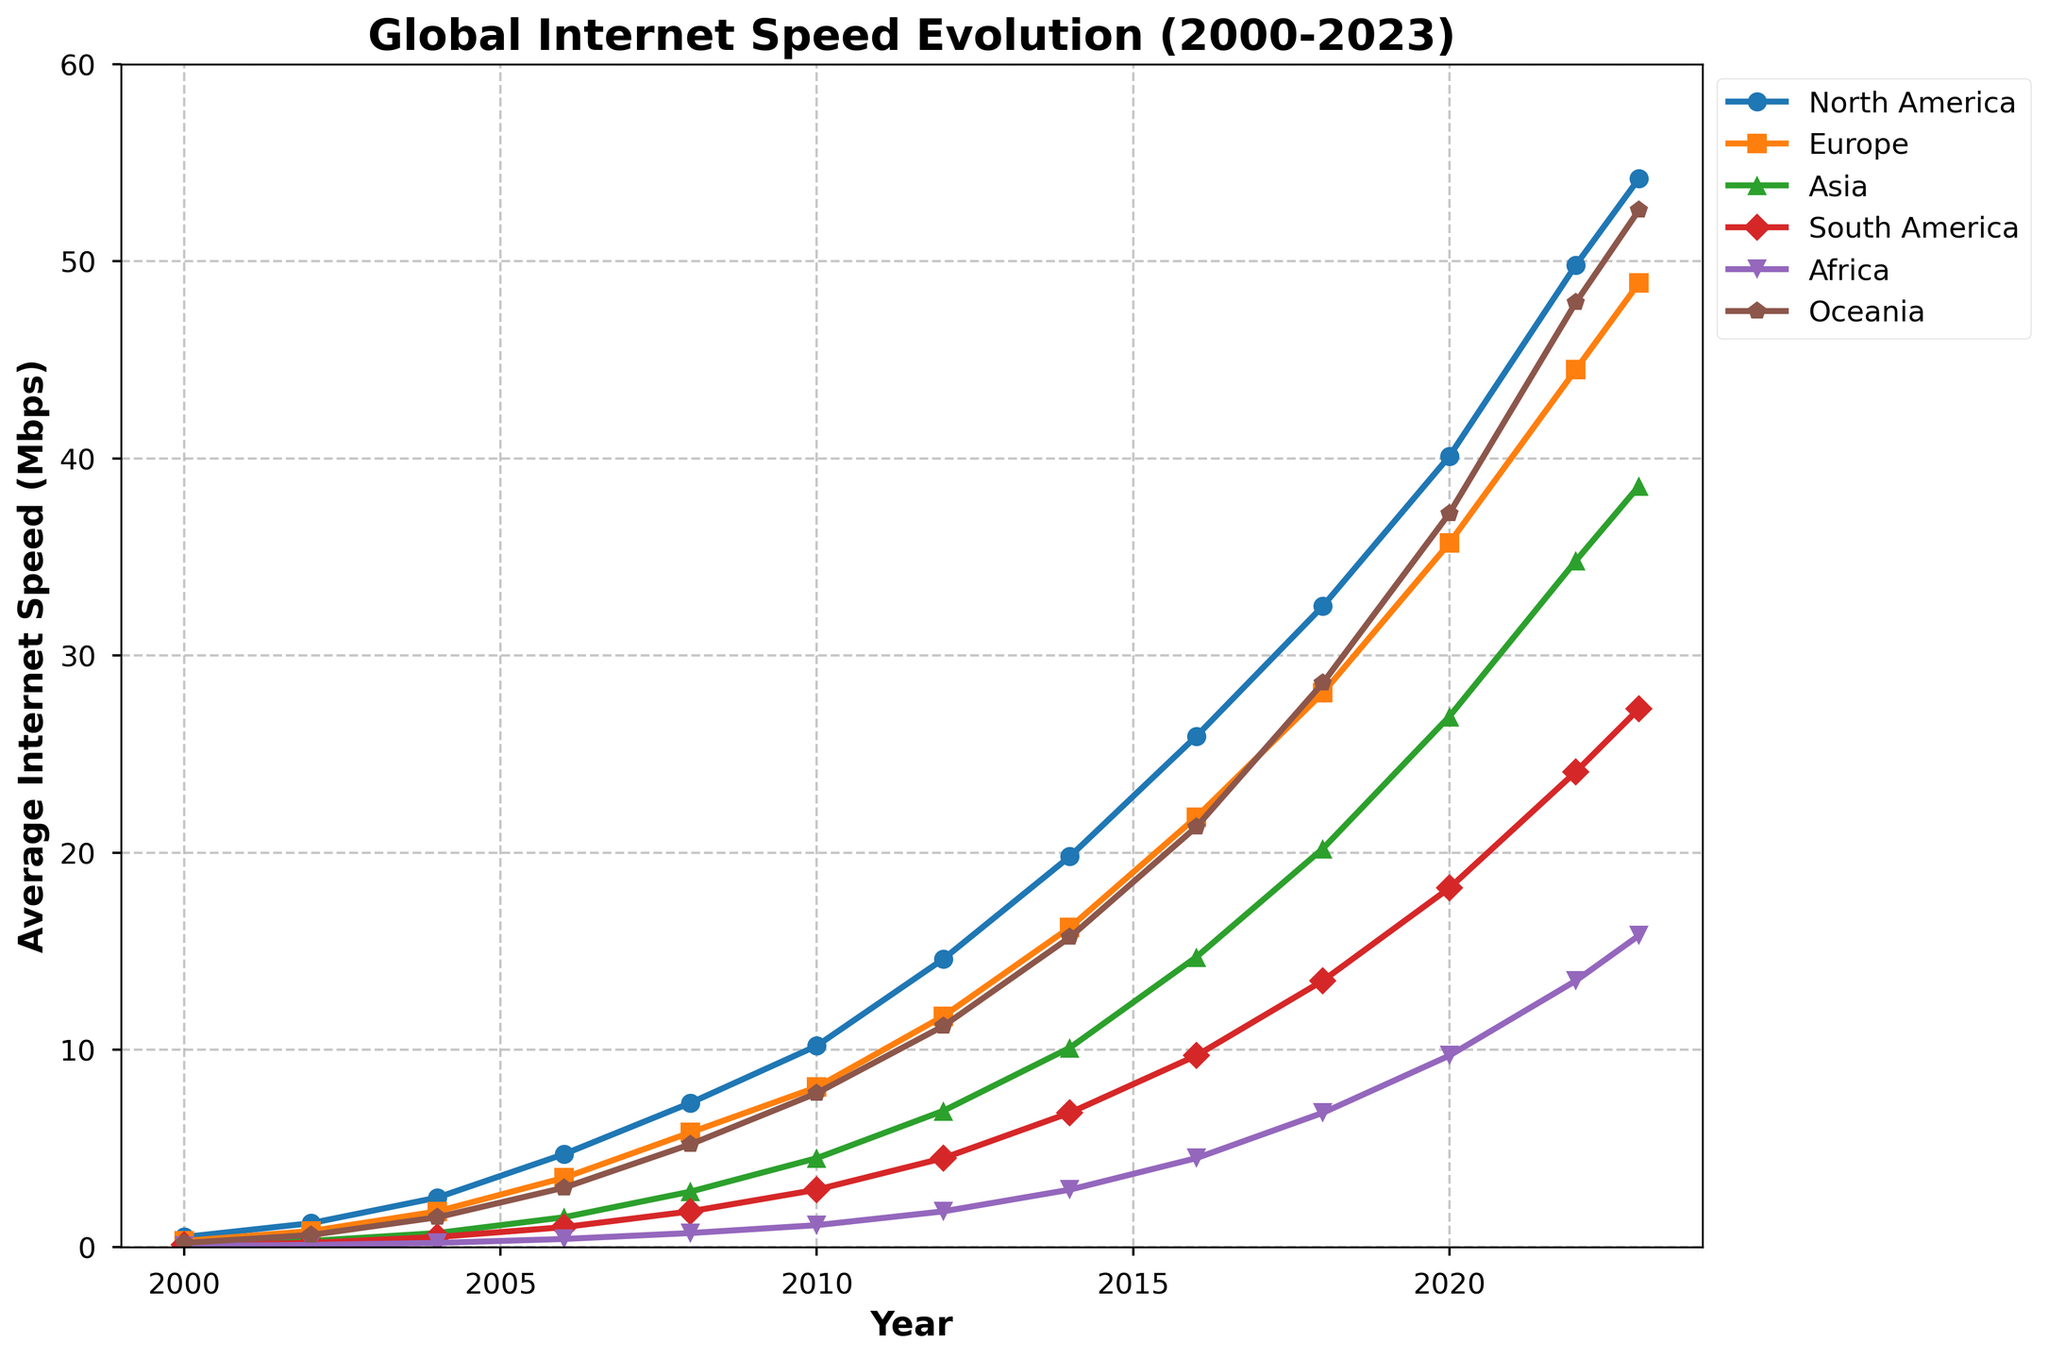Which continent had the highest average internet speed in 2023? By looking at the plot, the curve for Oceania in 2023 is the highest among the continents.
Answer: Oceania What was the average internet speed in Africa in 2010 compared to 2020? In 2010, Africa had an average speed of 1.1 Mbps. By 2020, it had increased to 9.7 Mbps. The increase is calculated as 9.7 - 1.1 = 8.6 Mbps.
Answer: 8.6 Mbps Which two continents had the closest average internet speeds in 2018, and what were those speeds? Observing the 2018 data points, Asia and North America had close values with Asia at 20.2 Mbps and North America at 32.5 Mbps. Among all, the closest speeds are Europe at 28.1 Mbps and Oceania at 28.6 Mbps, with a difference of just 0.5 Mbps.
Answer: Europe and Oceania, 28.1 Mbps and 28.6 Mbps How did the average internet speed in South America change between 2006 and 2018? In 2006, South America's average was 1.0 Mbps, and in 2018, it was 13.5 Mbps. The change is 13.5 - 1.0 = 12.5 Mbps.
Answer: 12.5 Mbps Compare the growth in average internet speed of North America and Asia from 2004 to 2022. Which one grew more, and by how much? In 2004, North America was at 2.5 Mbps and in 2022 at 49.8 Mbps. The increase for North America is 49.8 - 2.5 = 47.3 Mbps. Asia was at 0.7 Mbps in 2004 and 34.8 Mbps in 2022, so its increase is 34.8 - 0.7 = 34.1 Mbps. North America grew more by 47.3 - 34.1 = 13.2 Mbps.
Answer: North America, by 13.2 Mbps What is the approximate difference in average internet speeds between 2000 and 2023 for Oceania? In 2000, Oceania's average speed was 0.2 Mbps, and in 2023, it was 52.6 Mbps. The difference is 52.6 - 0.2 = 52.4 Mbps.
Answer: 52.4 Mbps Identify the continent with the most significant relative increase in internet speed from 2000 to 2023 and describe that increase. Africa in 2000 was at 0.05 Mbps and in 2023 at 15.8 Mbps. Calculating the relative (percentage) increase: (15.8 - 0.05) / 0.05 * 100% = 31,500%.
Answer: Africa, 31,500% How does the average internet speed trend for Europe from 2000 to 2023 compare to the trend for South America over the same period? Europe shows a steady increase from 0.3 Mbps in 2000 to 48.9 Mbps in 2023. South America's increase is from 0.1 Mbps in 2000 to 27.3 Mbps in 2023. Both continents show consistent growth, but Europe has a higher overall speed in all years.
Answer: Steady increase for both, Europe higher overall What was the average internet speed in Asia in 2012, and how much did it increase by 2022? In 2012, Asia had an average speed of 6.9 Mbps, and by 2022, it was 34.8 Mbps. The increase is 34.8 - 6.9 = 27.9 Mbps.
Answer: 27.9 Mbps 